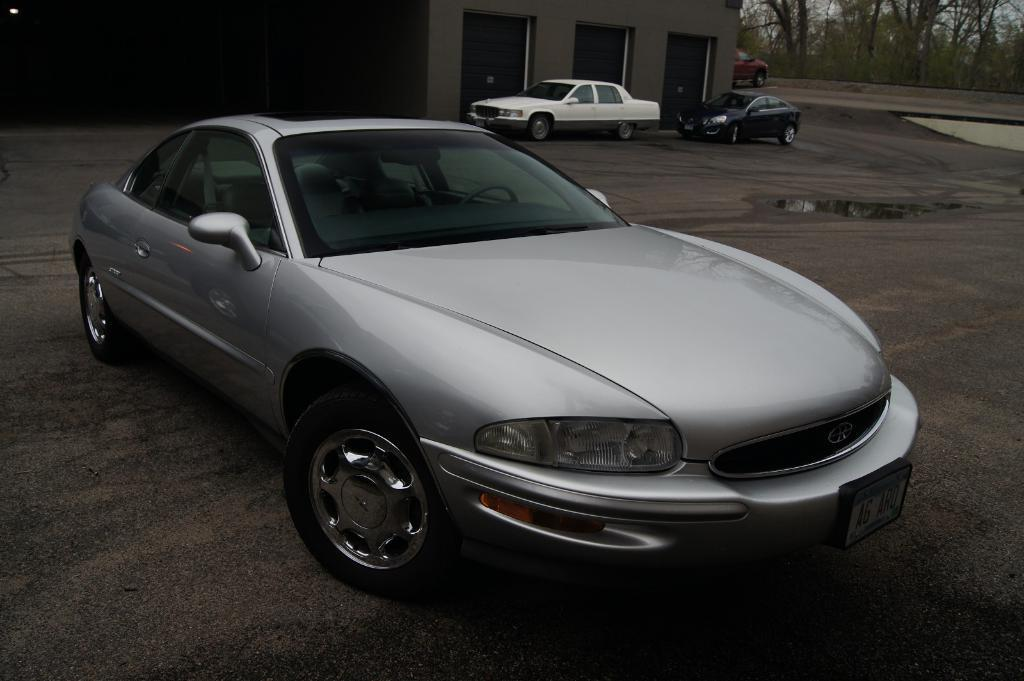What type of vehicles can be seen in the image? There are cars in the image. What is visible in the background of the image? There is a building and trees in the background of the image. What is at the bottom of the image? There is a road at the bottom of the image. What natural element can be seen in the image? Water is visible in the image. What type of bells can be heard ringing in the image? There are no bells present in the image, and therefore no sound can be heard. 